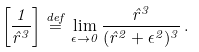Convert formula to latex. <formula><loc_0><loc_0><loc_500><loc_500>\left [ \frac { 1 } { { \hat { r } } ^ { 3 } } \right ] \stackrel { d e f } { = } \lim _ { \epsilon \rightarrow 0 } \frac { \hat { r } ^ { 3 } } { ( \hat { r } ^ { 2 } + \epsilon ^ { 2 } ) ^ { 3 } } \, .</formula> 